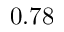Convert formula to latex. <formula><loc_0><loc_0><loc_500><loc_500>0 . 7 8</formula> 